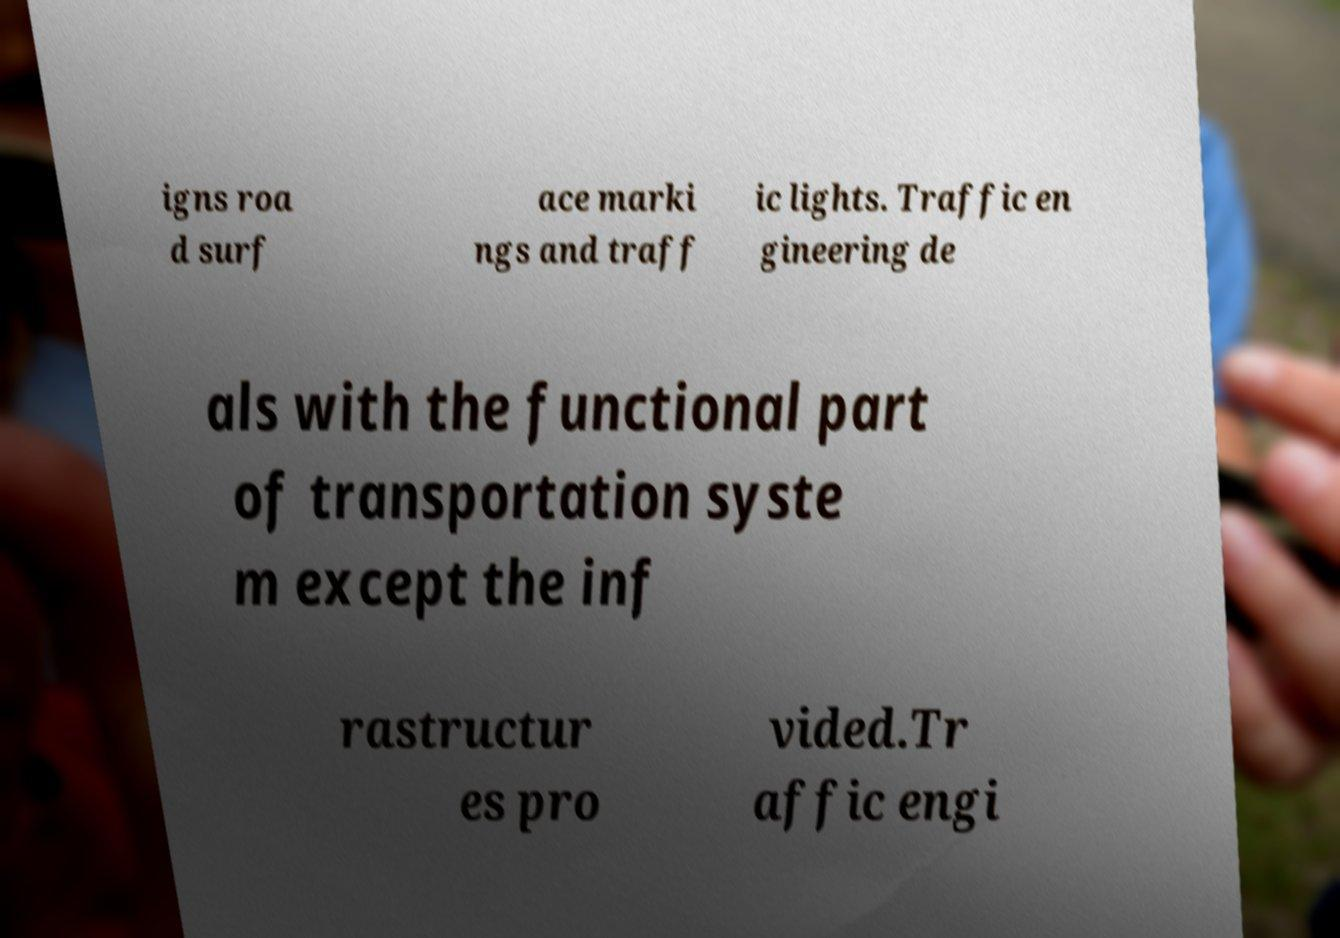I need the written content from this picture converted into text. Can you do that? igns roa d surf ace marki ngs and traff ic lights. Traffic en gineering de als with the functional part of transportation syste m except the inf rastructur es pro vided.Tr affic engi 